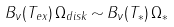Convert formula to latex. <formula><loc_0><loc_0><loc_500><loc_500>B _ { \nu } ( T _ { e x } ) \, { \Omega } _ { d i s k } \, { \sim } \, B _ { \nu } ( T _ { * } ) \, { \Omega } _ { * }</formula> 